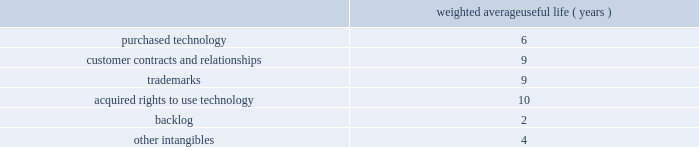Table of contents adobe inc .
Notes to consolidated financial statements ( continued ) goodwill , purchased intangibles and other long-lived assets goodwill is assigned to one or more reporting segments on the date of acquisition .
We review our goodwill for impairment annually during our second quarter of each fiscal year and between annual tests if an event occurs or circumstances change that would more likely than not reduce the fair value of any one of our reporting units below its respective carrying amount .
In performing our goodwill impairment test , we first perform a qualitative assessment , which requires that we consider events or circumstances including macroeconomic conditions , industry and market considerations , cost factors , overall financial performance , changes in management or key personnel , changes in strategy , changes in customers , changes in the composition or carrying amount of a reporting segment 2019s net assets and changes in our stock price .
If , after assessing the totality of events or circumstances , we determine that it is more likely than not that the fair values of our reporting segments are greater than the carrying amounts , then the quantitative goodwill impairment test is not performed .
If the qualitative assessment indicates that the quantitative analysis should be performed , we then evaluate goodwill for impairment by comparing the fair value of each of our reporting segments to its carrying value , including the associated goodwill .
To determine the fair values , we use the equal weighting of the market approach based on comparable publicly traded companies in similar lines of businesses and the income approach based on estimated discounted future cash flows .
Our cash flow assumptions consider historical and forecasted revenue , operating costs and other relevant factors .
We completed our annual goodwill impairment test in the second quarter of fiscal 2018 .
We determined , after performing a qualitative review of each reporting segment , that it is more likely than not that the fair value of each of our reporting segments substantially exceeds the respective carrying amounts .
Accordingly , there was no indication of impairment and the quantitative goodwill impairment test was not performed .
We did not identify any events or changes in circumstances since the performance of our annual goodwill impairment test that would require us to perform another goodwill impairment test during the fiscal year .
We amortize intangible assets with finite lives over their estimated useful lives and review them for impairment whenever an impairment indicator exists .
We continually monitor events and changes in circumstances that could indicate carrying amounts of our long-lived assets , including our intangible assets may not be recoverable .
When such events or changes in circumstances occur , we assess recoverability by determining whether the carrying value of such assets will be recovered through the undiscounted expected future cash flows .
If the future undiscounted cash flows are less than the carrying amount of these assets , we recognize an impairment loss based on any excess of the carrying amount over the fair value of the assets .
We did not recognize any intangible asset impairment charges in fiscal 2018 , 2017 or 2016 .
During fiscal 2018 , our intangible assets were amortized over their estimated useful lives ranging from 1 to 14 years .
Amortization is based on the pattern in which the economic benefits of the intangible asset will be consumed or on a straight-line basis when the consumption pattern is not apparent .
The weighted average useful lives of our intangible assets were as follows : weighted average useful life ( years ) .
Income taxes we use the asset and liability method of accounting for income taxes .
Under this method , income tax expense is recognized for the amount of taxes payable or refundable for the current year .
In addition , deferred tax assets and liabilities are recognized for expected future tax consequences of temporary differences between the financial reporting and tax bases of assets and liabilities , and for operating losses and tax credit carryforwards .
We record a valuation allowance to reduce deferred tax assets to an amount for which realization is more likely than not. .
What is the average yearly amortization expense related to purchased technology? 
Computations: (100 / 6)
Answer: 16.66667. Table of contents adobe inc .
Notes to consolidated financial statements ( continued ) goodwill , purchased intangibles and other long-lived assets goodwill is assigned to one or more reporting segments on the date of acquisition .
We review our goodwill for impairment annually during our second quarter of each fiscal year and between annual tests if an event occurs or circumstances change that would more likely than not reduce the fair value of any one of our reporting units below its respective carrying amount .
In performing our goodwill impairment test , we first perform a qualitative assessment , which requires that we consider events or circumstances including macroeconomic conditions , industry and market considerations , cost factors , overall financial performance , changes in management or key personnel , changes in strategy , changes in customers , changes in the composition or carrying amount of a reporting segment 2019s net assets and changes in our stock price .
If , after assessing the totality of events or circumstances , we determine that it is more likely than not that the fair values of our reporting segments are greater than the carrying amounts , then the quantitative goodwill impairment test is not performed .
If the qualitative assessment indicates that the quantitative analysis should be performed , we then evaluate goodwill for impairment by comparing the fair value of each of our reporting segments to its carrying value , including the associated goodwill .
To determine the fair values , we use the equal weighting of the market approach based on comparable publicly traded companies in similar lines of businesses and the income approach based on estimated discounted future cash flows .
Our cash flow assumptions consider historical and forecasted revenue , operating costs and other relevant factors .
We completed our annual goodwill impairment test in the second quarter of fiscal 2018 .
We determined , after performing a qualitative review of each reporting segment , that it is more likely than not that the fair value of each of our reporting segments substantially exceeds the respective carrying amounts .
Accordingly , there was no indication of impairment and the quantitative goodwill impairment test was not performed .
We did not identify any events or changes in circumstances since the performance of our annual goodwill impairment test that would require us to perform another goodwill impairment test during the fiscal year .
We amortize intangible assets with finite lives over their estimated useful lives and review them for impairment whenever an impairment indicator exists .
We continually monitor events and changes in circumstances that could indicate carrying amounts of our long-lived assets , including our intangible assets may not be recoverable .
When such events or changes in circumstances occur , we assess recoverability by determining whether the carrying value of such assets will be recovered through the undiscounted expected future cash flows .
If the future undiscounted cash flows are less than the carrying amount of these assets , we recognize an impairment loss based on any excess of the carrying amount over the fair value of the assets .
We did not recognize any intangible asset impairment charges in fiscal 2018 , 2017 or 2016 .
During fiscal 2018 , our intangible assets were amortized over their estimated useful lives ranging from 1 to 14 years .
Amortization is based on the pattern in which the economic benefits of the intangible asset will be consumed or on a straight-line basis when the consumption pattern is not apparent .
The weighted average useful lives of our intangible assets were as follows : weighted average useful life ( years ) .
Income taxes we use the asset and liability method of accounting for income taxes .
Under this method , income tax expense is recognized for the amount of taxes payable or refundable for the current year .
In addition , deferred tax assets and liabilities are recognized for expected future tax consequences of temporary differences between the financial reporting and tax bases of assets and liabilities , and for operating losses and tax credit carryforwards .
We record a valuation allowance to reduce deferred tax assets to an amount for which realization is more likely than not. .
What is the average yearly amortization expense related to trademarks? 
Computations: (100 / 9)
Answer: 11.11111. Table of contents adobe inc .
Notes to consolidated financial statements ( continued ) goodwill , purchased intangibles and other long-lived assets goodwill is assigned to one or more reporting segments on the date of acquisition .
We review our goodwill for impairment annually during our second quarter of each fiscal year and between annual tests if an event occurs or circumstances change that would more likely than not reduce the fair value of any one of our reporting units below its respective carrying amount .
In performing our goodwill impairment test , we first perform a qualitative assessment , which requires that we consider events or circumstances including macroeconomic conditions , industry and market considerations , cost factors , overall financial performance , changes in management or key personnel , changes in strategy , changes in customers , changes in the composition or carrying amount of a reporting segment 2019s net assets and changes in our stock price .
If , after assessing the totality of events or circumstances , we determine that it is more likely than not that the fair values of our reporting segments are greater than the carrying amounts , then the quantitative goodwill impairment test is not performed .
If the qualitative assessment indicates that the quantitative analysis should be performed , we then evaluate goodwill for impairment by comparing the fair value of each of our reporting segments to its carrying value , including the associated goodwill .
To determine the fair values , we use the equal weighting of the market approach based on comparable publicly traded companies in similar lines of businesses and the income approach based on estimated discounted future cash flows .
Our cash flow assumptions consider historical and forecasted revenue , operating costs and other relevant factors .
We completed our annual goodwill impairment test in the second quarter of fiscal 2018 .
We determined , after performing a qualitative review of each reporting segment , that it is more likely than not that the fair value of each of our reporting segments substantially exceeds the respective carrying amounts .
Accordingly , there was no indication of impairment and the quantitative goodwill impairment test was not performed .
We did not identify any events or changes in circumstances since the performance of our annual goodwill impairment test that would require us to perform another goodwill impairment test during the fiscal year .
We amortize intangible assets with finite lives over their estimated useful lives and review them for impairment whenever an impairment indicator exists .
We continually monitor events and changes in circumstances that could indicate carrying amounts of our long-lived assets , including our intangible assets may not be recoverable .
When such events or changes in circumstances occur , we assess recoverability by determining whether the carrying value of such assets will be recovered through the undiscounted expected future cash flows .
If the future undiscounted cash flows are less than the carrying amount of these assets , we recognize an impairment loss based on any excess of the carrying amount over the fair value of the assets .
We did not recognize any intangible asset impairment charges in fiscal 2018 , 2017 or 2016 .
During fiscal 2018 , our intangible assets were amortized over their estimated useful lives ranging from 1 to 14 years .
Amortization is based on the pattern in which the economic benefits of the intangible asset will be consumed or on a straight-line basis when the consumption pattern is not apparent .
The weighted average useful lives of our intangible assets were as follows : weighted average useful life ( years ) .
Income taxes we use the asset and liability method of accounting for income taxes .
Under this method , income tax expense is recognized for the amount of taxes payable or refundable for the current year .
In addition , deferred tax assets and liabilities are recognized for expected future tax consequences of temporary differences between the financial reporting and tax bases of assets and liabilities , and for operating losses and tax credit carryforwards .
We record a valuation allowance to reduce deferred tax assets to an amount for which realization is more likely than not. .
Was the weighted average useful life for trademarks greater than that of acquired rights to use technology? 
Computations: (9 > 10)
Answer: no. 